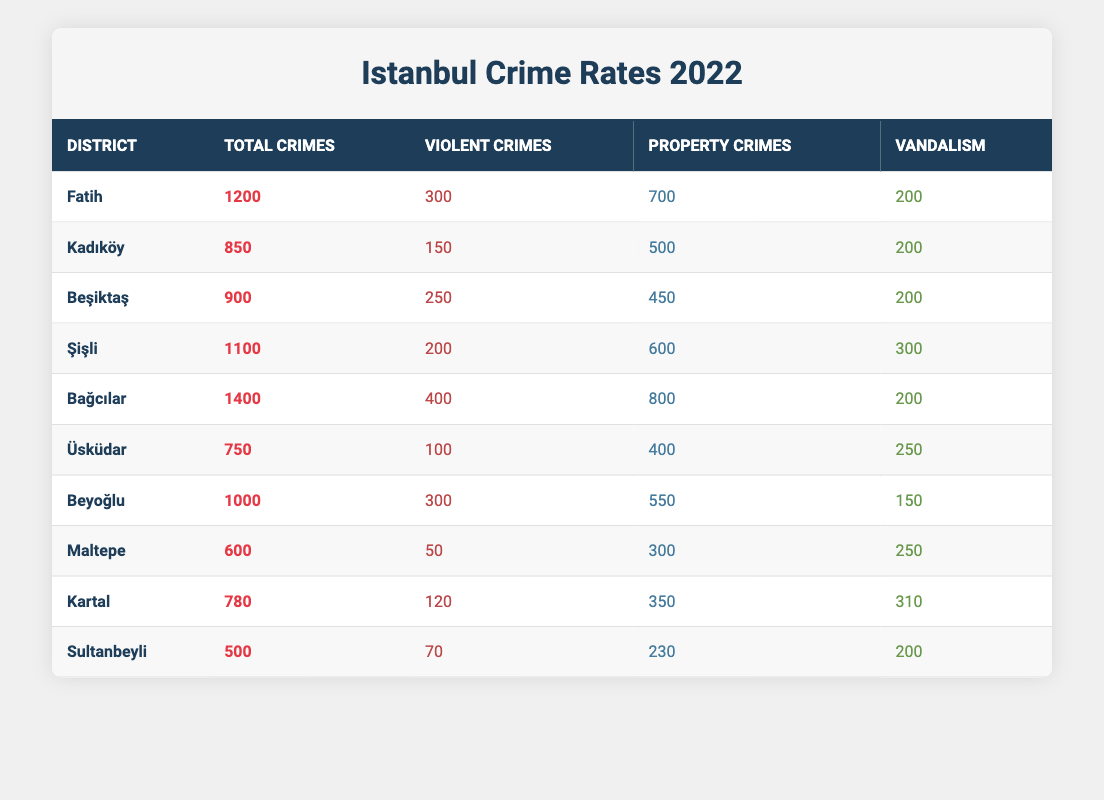What district has the highest total crime rate? By inspecting the table, we look through the "Total Crimes" column and find the highest value, which is 1400 in the "Bağcılar" row, indicating that it has the highest total crime rate.
Answer: Bağcılar Which district had the least violent crimes? In the table, we check the "Violent Crimes" column for the lowest value, which is 50 associated with "Maltepe". This indicates that it had the least violent crimes in 2022.
Answer: Maltepe What is the total number of property crimes reported in Istanbul in 2022? To find the total property crimes, we sum all values in the "Property Crimes" column: 700 + 500 + 450 + 600 + 800 + 400 + 550 + 300 + 350 + 230 = 6,630. Thus, the total number of property crimes reported is 6,630.
Answer: 6630 Is it true that Üsküdar had more vandalism incidents than Sultanbeyli? By comparing values in the "Vandalism" row, Üsküdar has 250 incidents and Sultanbeyli has 200 incidents. Since 250 is greater than 200, the statement is true.
Answer: Yes What is the average number of violent crimes across all the districts in the table? First, we sum the "Violent Crimes" across all districts: 300 + 150 + 250 + 200 + 400 + 100 + 300 + 50 + 120 + 70 = 1,940. There are 10 districts, so we calculate the average as 1,940 divided by 10, giving us 194.
Answer: 194 Which districts reported more than 200 incidents of vandalism? We review the "Vandalism" column for values greater than 200. The districts with such incidents are "Şişli" (300), "Üsküdar" (250), and "Kartal" (310). Therefore, those are the districts reporting more than 200 vandalism incidents.
Answer: Şişli, Üsküdar, Kartal How many total crimes were reported in the Beşiktaş district? The "Total Crimes" column shows the number for Beşiktaş as 900. By directly referring to this value in the table, we find the total crimes reported in Beşiktaş.
Answer: 900 Was the total number of violent crimes in Kadıköy higher than in Fatih? By checking the "Violent Crimes" values in both districts, Kadıköy has 150 and Fatih has 300. Since 150 is less than 300, the assertion is false.
Answer: No What percentage of the total crimes in Bağcılar were violent crimes? First, we take the total violent crimes in Bağcılar (400) and divide it by the total crimes (1400), which is 400/1400. This results in 0.2857 or approximately 28.57%. To express this as a percentage, we multiply by 100, getting about 28.57%.
Answer: 28.57% 